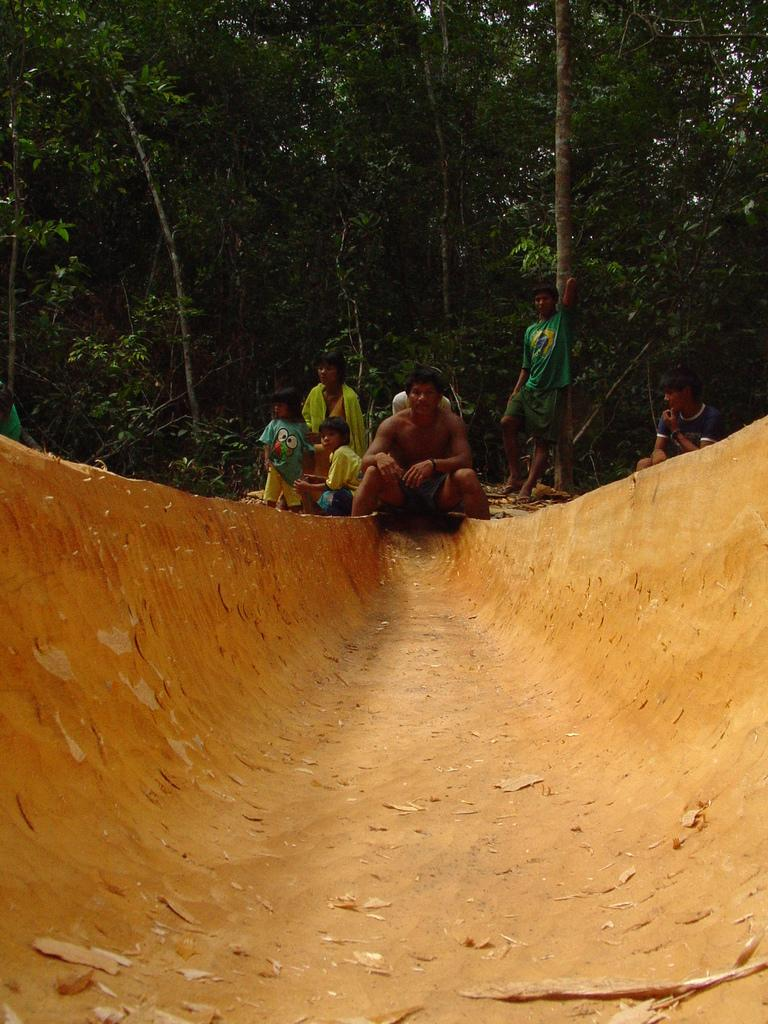What is the main subject of the picture? The main subject of the picture is a muddy tunnel. Who or what is inside the tunnel? A man, two kids, and a woman are present in the tunnel. What can be seen behind the tunnel? Trees are visible behind the tunnel. What type of detail can be seen on the trucks in the image? There are no trucks present in the image, so there are no details to observe on them. 